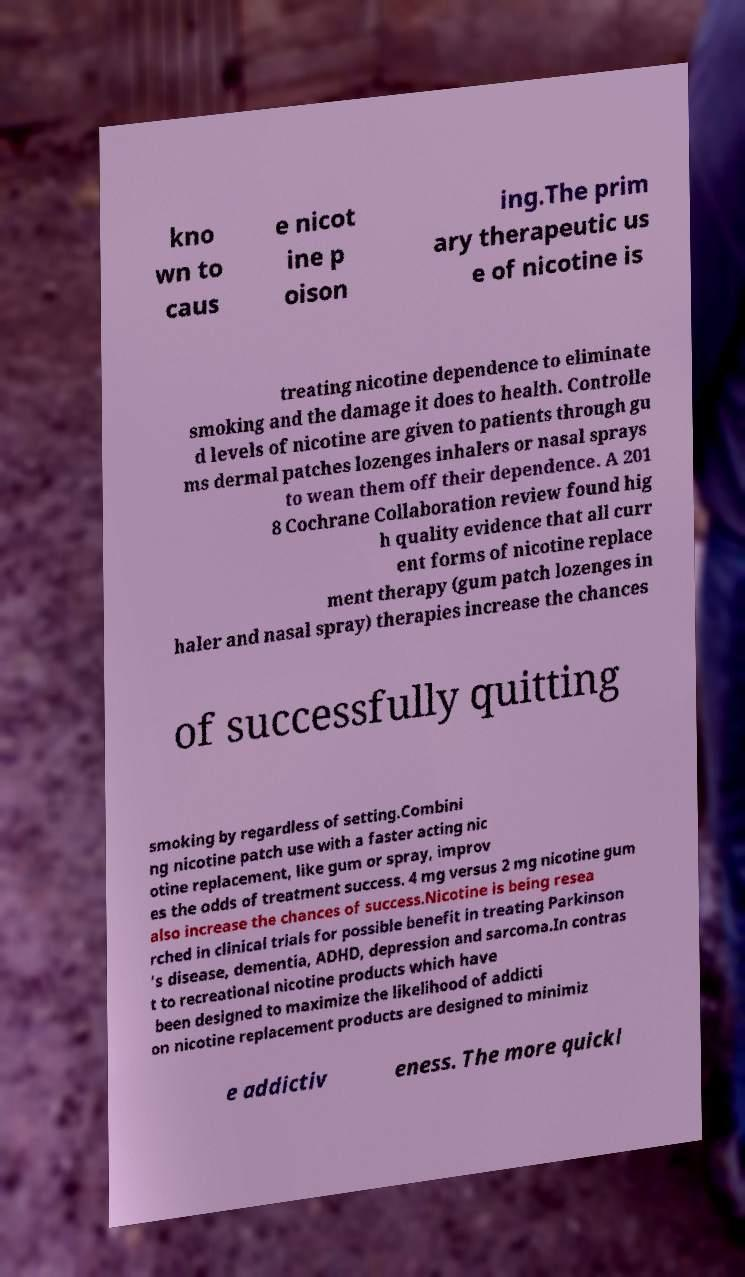Could you extract and type out the text from this image? kno wn to caus e nicot ine p oison ing.The prim ary therapeutic us e of nicotine is treating nicotine dependence to eliminate smoking and the damage it does to health. Controlle d levels of nicotine are given to patients through gu ms dermal patches lozenges inhalers or nasal sprays to wean them off their dependence. A 201 8 Cochrane Collaboration review found hig h quality evidence that all curr ent forms of nicotine replace ment therapy (gum patch lozenges in haler and nasal spray) therapies increase the chances of successfully quitting smoking by regardless of setting.Combini ng nicotine patch use with a faster acting nic otine replacement, like gum or spray, improv es the odds of treatment success. 4 mg versus 2 mg nicotine gum also increase the chances of success.Nicotine is being resea rched in clinical trials for possible benefit in treating Parkinson 's disease, dementia, ADHD, depression and sarcoma.In contras t to recreational nicotine products which have been designed to maximize the likelihood of addicti on nicotine replacement products are designed to minimiz e addictiv eness. The more quickl 